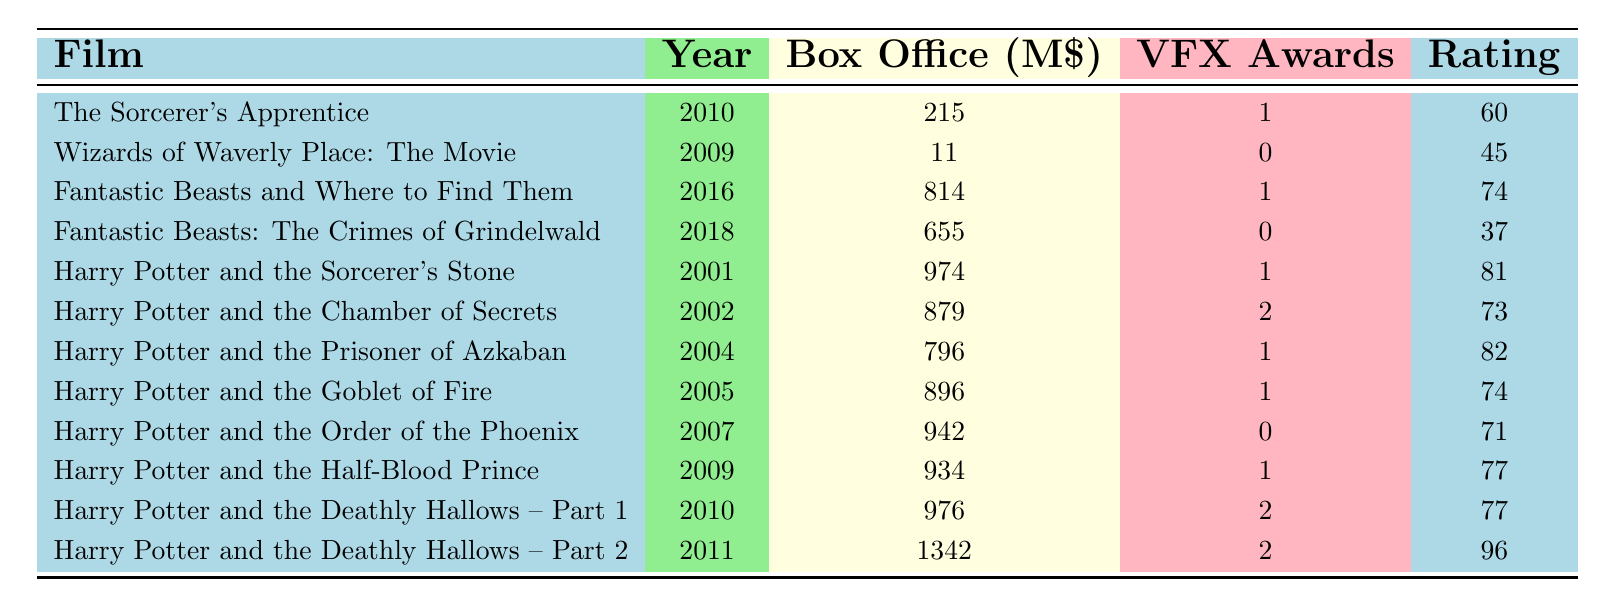What is the box office gross of "Harry Potter and the Deathly Hallows – Part 2"? The table shows the specific film "Harry Potter and the Deathly Hallows – Part 2" along with its box office gross value. Referring directly to that row, the box office gross is noted as 1342000000.
Answer: 1342000000 Which film was released in 2009 and had the highest box office gross? By examining the films released in 2009, we see "Wizards of Waverly Place: The Movie" with a box office gross of 11000000 and "Harry Potter and the Half-Blood Prince" with a gross of 934000000. The latter has the higher value.
Answer: Harry Potter and the Half-Blood Prince How many visual effects awards did "Fantastic Beasts: The Crimes of Grindelwald" receive? Directly looking at the row corresponding to "Fantastic Beasts: The Crimes of Grindelwald," we find that it received 0 visual effects awards.
Answer: 0 Calculate the average box office gross of all the Harry Potter films. The box office grosses for Harry Potter films include: 974000000, 879000000, 796000000, 896000000, 942000000, 934000000, 976000000, and 1342000000. Summing these values (974 + 879 + 796 + 896 + 942 + 934 + 976 + 1342) gives a total of 7270 million. There are 8 films, so dividing by 8 gives an average of 909 million.
Answer: 909000000 Did any film in the series receive more than one visual effects award? By examining each row, we see that "Harry Potter and the Chamber of Secrets" and "Harry Potter and the Deathly Hallows – Part 1" both received more than one visual effects award (2 in total). Thus, the fact is true.
Answer: Yes Which film has the lowest critical rating in the table? Looking across the critical rating column, "Fantastic Beasts: The Crimes of Grindelwald" has the lowest rating of 37. This can be confirmed by scanning for the smallest number in that column.
Answer: Fantastic Beasts: The Crimes of Grindelwald What is the difference in box office gross between "Harry Potter and the Chamber of Secrets" and "Harry Potter and the Goblet of Fire"? The box office gross for "Harry Potter and the Chamber of Secrets" is 879000000 and for "Harry Potter and the Goblet of Fire" it is 896000000. Calculating the difference (896000000 - 879000000) gives 17000000.
Answer: 17000000 Which film had both a high box office gross and a high critical rating? Upon review, "Harry Potter and the Deathly Hallows – Part 2" stands out with a box office gross of 1342000000 and a critical rating of 96, indicating it performs well in both aspects.
Answer: Harry Potter and the Deathly Hallows – Part 2 